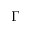Convert formula to latex. <formula><loc_0><loc_0><loc_500><loc_500>\Gamma</formula> 